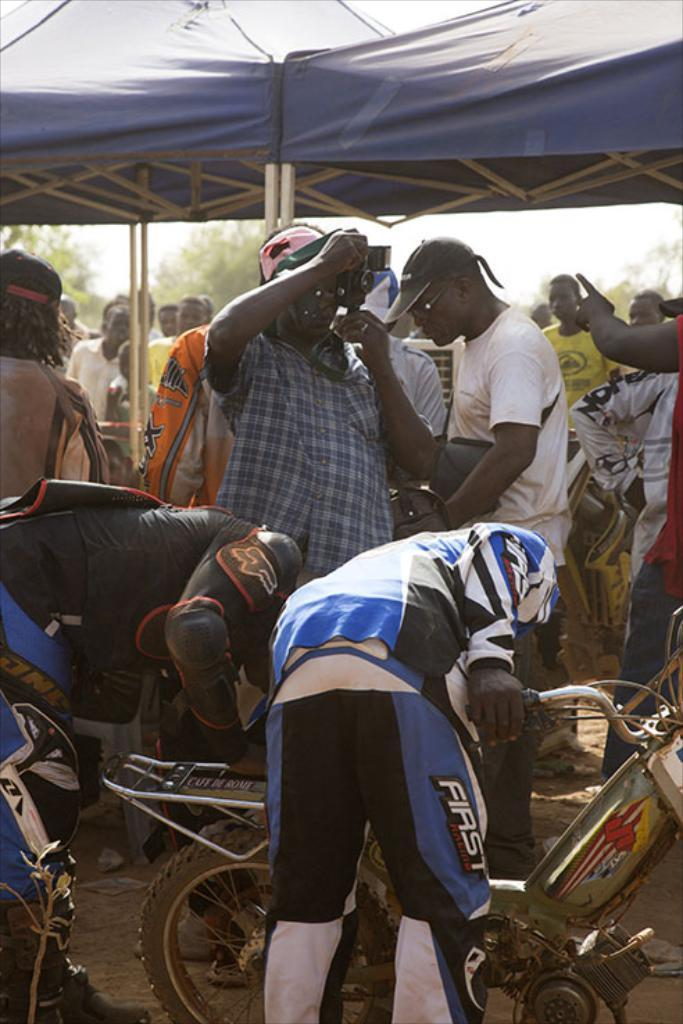What are the people in the image doing? The people in the image are standing. What can be seen in the foreground of the image? There is a person holding a bike in the foreground of the image. What type of vegetation is visible in the background of the image? There are trees in the background of the image. What type of shelter is present in the background of the image? There is a tent in the background of the image. What type of owl can be seen perched on the bike in the image? There is no owl present in the image; it only features people, a bike, trees, and a tent. 